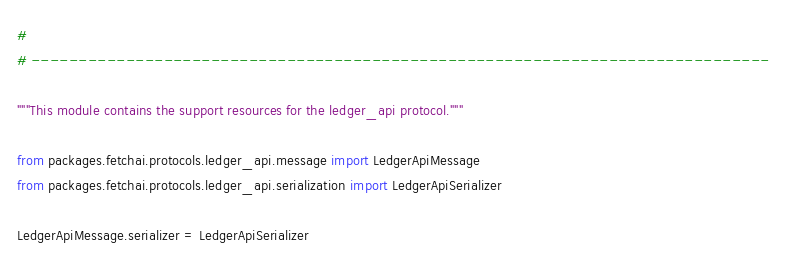Convert code to text. <code><loc_0><loc_0><loc_500><loc_500><_Python_>#
# ------------------------------------------------------------------------------

"""This module contains the support resources for the ledger_api protocol."""

from packages.fetchai.protocols.ledger_api.message import LedgerApiMessage
from packages.fetchai.protocols.ledger_api.serialization import LedgerApiSerializer

LedgerApiMessage.serializer = LedgerApiSerializer
</code> 